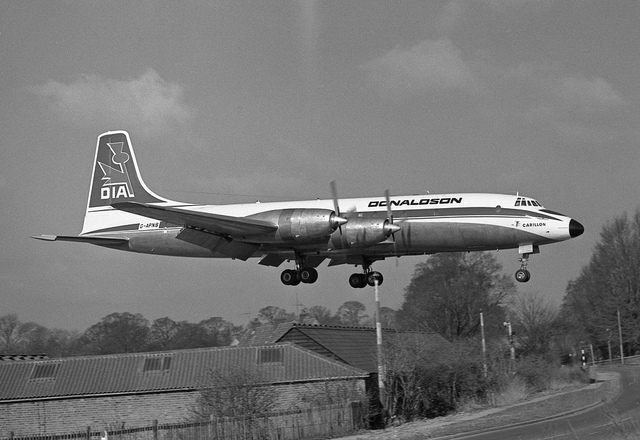Read and extract the text from this image. DIA 